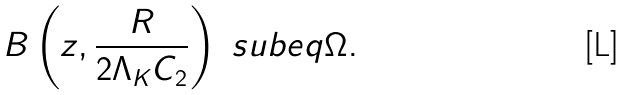<formula> <loc_0><loc_0><loc_500><loc_500>B \left ( z , \frac { R } { 2 \Lambda _ { K } C _ { 2 } } \right ) \ s u b e q \Omega .</formula> 